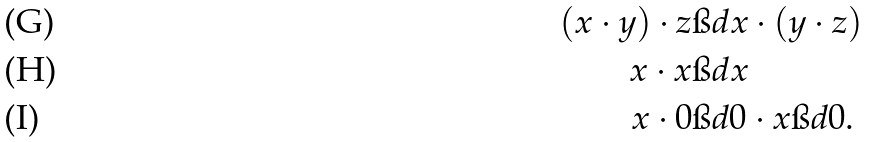<formula> <loc_0><loc_0><loc_500><loc_500>( x \cdot y ) \cdot z & \i d x \cdot ( y \cdot z ) \\ x \cdot x & \i d x \\ x \cdot 0 & \i d 0 \cdot x \i d 0 .</formula> 